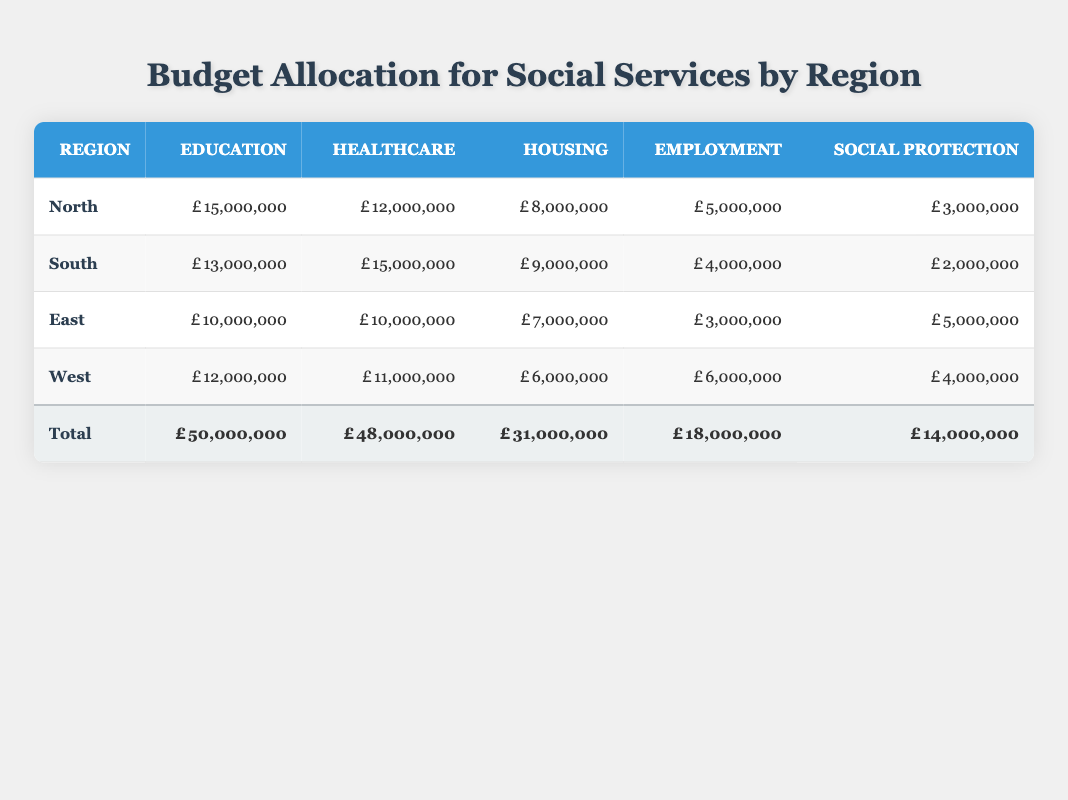What is the total budget allocated for healthcare in the South region? The table indicates that the healthcare allocation for the South region is 15,000,000. This is a direct retrieval from the South row under the Healthcare column.
Answer: 15,000,000 Which region has the highest budget allocation for housing? By comparing the housing allocations across all regions, North has 8,000,000, South has 9,000,000, East has 7,000,000, and West has 6,000,000. The South region has the highest value at 9,000,000.
Answer: South What is the total budget for social protection across all regions? The total allocation for social protection can be found in the total row, which states that the total is 14,000,000. This is a direct retrieval from the 'Total' section of the table.
Answer: 14,000,000 What is the average budget allocation for employment across all regions? The employment allocations are as follows: North 5,000,000, South 4,000,000, East 3,000,000, West 6,000,000. First, we sum these values: (5,000,000 + 4,000,000 + 3,000,000 + 6,000,000) = 18,000,000. There are 4 regions, so the average is 18,000,000 / 4 = 4,500,000.
Answer: 4,500,000 Is it true that the East region spent more on healthcare than on education? The East region's allocations indicate 10,000,000 for healthcare and 10,000,000 for education. Since both are equal, the statement is false because healthcare is not greater than education; they are the same.
Answer: No Which region has the lowest total budget allocation for social services? By adding each region's total allocation, we find: North (30,000,000), South (33,000,000), East (25,000,000), West (29,000,000). East has the lowest total at 25,000,000.
Answer: East How much more is spent on education in the North compared to the West? The North has an education allocation of 15,000,000, and the West has 12,000,000. To find the difference, we subtract the West’s amount from the North’s: 15,000,000 - 12,000,000 = 3,000,000.
Answer: 3,000,000 True or False: The total budget allocation for housing is less than the total for employment across all regions. The total for housing is 31,000,000, and for employment, it is 18,000,000. Since 31,000,000 is greater than 18,000,000, the statement is false.
Answer: False 